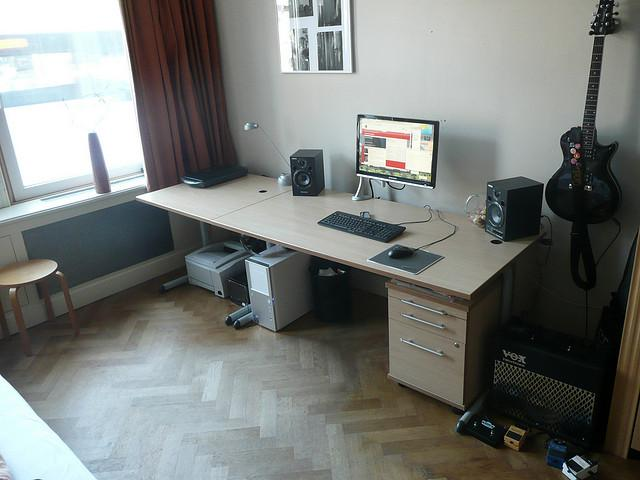What is the device on the floor under the desk near the wall? Please explain your reasoning. printer. There is a computer printer under the desk, near the wall. 